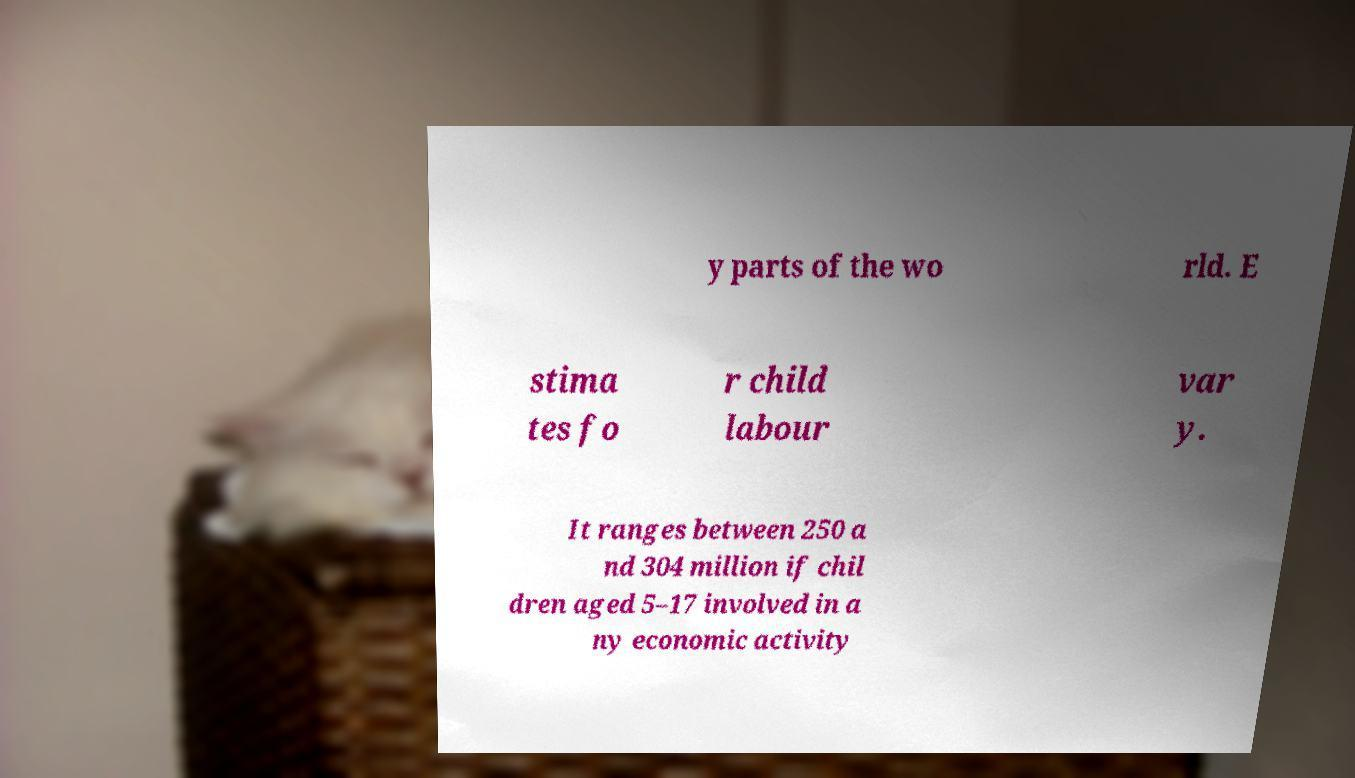Please read and relay the text visible in this image. What does it say? y parts of the wo rld. E stima tes fo r child labour var y. It ranges between 250 a nd 304 million if chil dren aged 5–17 involved in a ny economic activity 